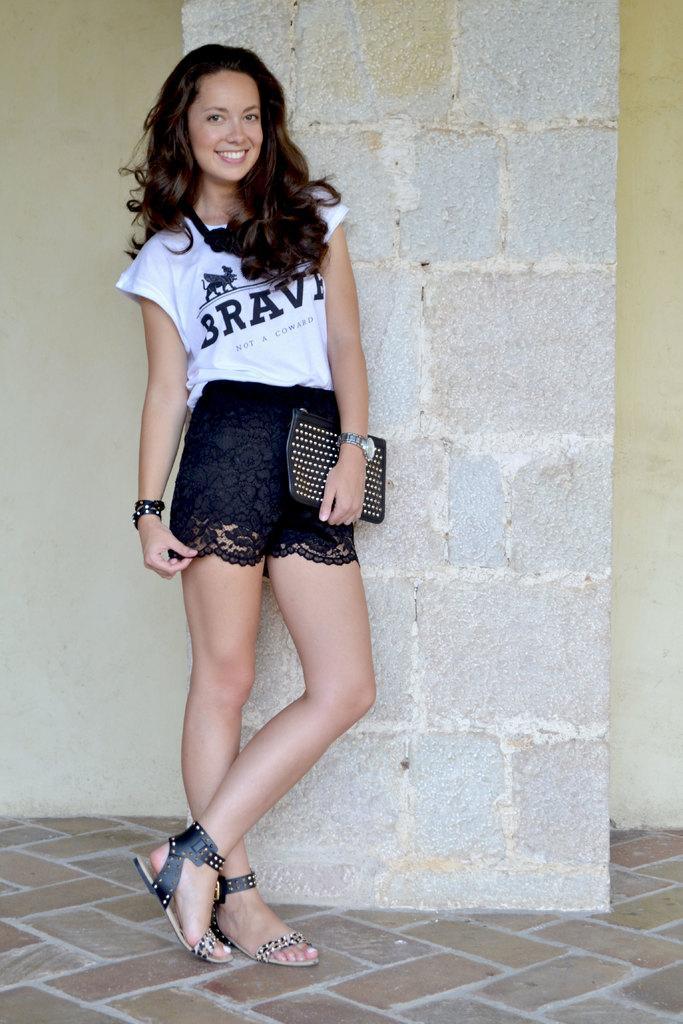Please provide a concise description of this image. In this image we can see a girl is standing and smiling. She is wearing white top with black skirt. Behind wall is there. 